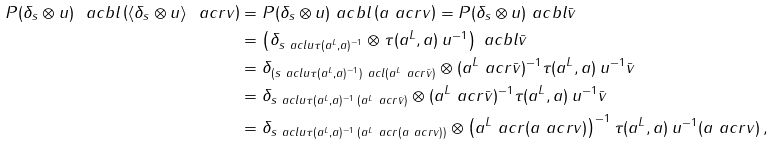Convert formula to latex. <formula><loc_0><loc_0><loc_500><loc_500>P ( \delta _ { s } \otimes u ) \ a c b l \left ( \langle \delta _ { s } \otimes u \rangle \ a c r v \right ) & = P ( \delta _ { s } \otimes u ) \ a c b l \left ( a \ a c r v \right ) = P ( \delta _ { s } \otimes u ) \ a c b l \bar { v } \\ & = \left ( \delta _ { s \ a c l u \tau ( a ^ { L } , a ) ^ { - 1 } } \otimes \tau ( a ^ { L } , a ) \, u ^ { - 1 } \right ) \ a c b l \bar { v } \\ & = \delta _ { ( s \ a c l u \tau ( a ^ { L } , a ) ^ { - 1 } ) \ a c l ( a ^ { L } \ a c r \bar { v } ) } \otimes ( a ^ { L } \ a c r \bar { v } ) ^ { - 1 } \tau ( a ^ { L } , a ) \, u ^ { - 1 } \bar { v } \\ & = \delta _ { s \ a c l u \tau ( a ^ { L } , a ) ^ { - 1 } \, ( a ^ { L } \ a c r \bar { v } ) } \otimes ( a ^ { L } \ a c r \bar { v } ) ^ { - 1 } \tau ( a ^ { L } , a ) \, u ^ { - 1 } \bar { v } \\ & = \delta _ { s \ a c l u \tau ( a ^ { L } , a ) ^ { - 1 } \, ( a ^ { L } \ a c r ( a \ a c r v ) ) } \otimes \left ( a ^ { L } \ a c r ( a \ a c r v ) \right ) ^ { - 1 } \tau ( a ^ { L } , a ) \, u ^ { - 1 } ( a \ a c r v ) \, ,</formula> 